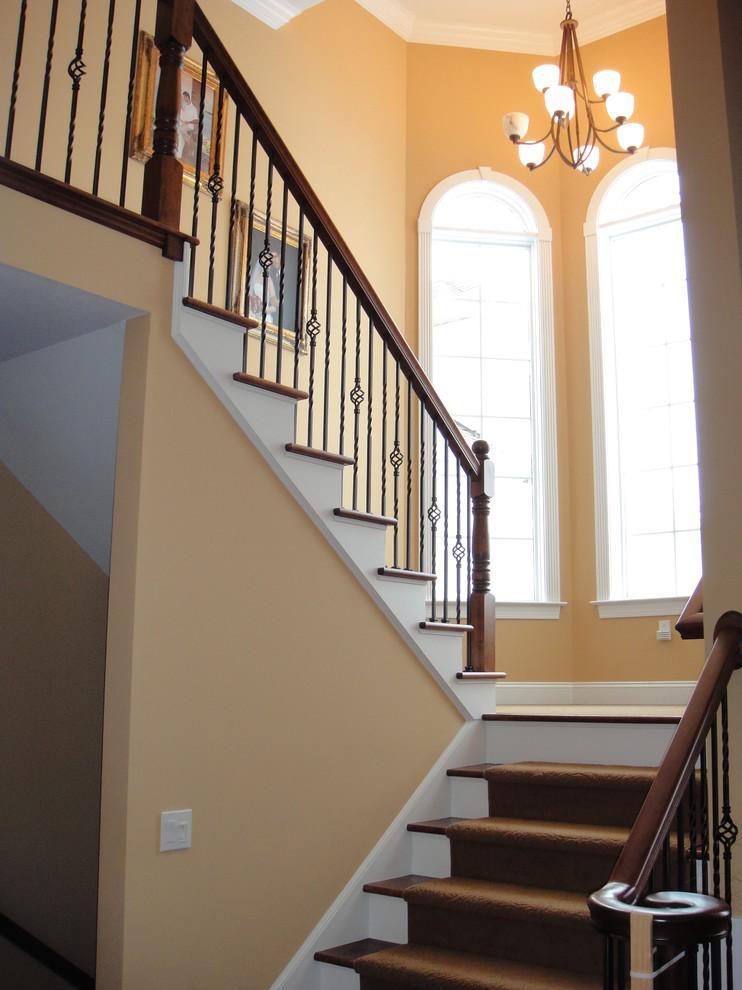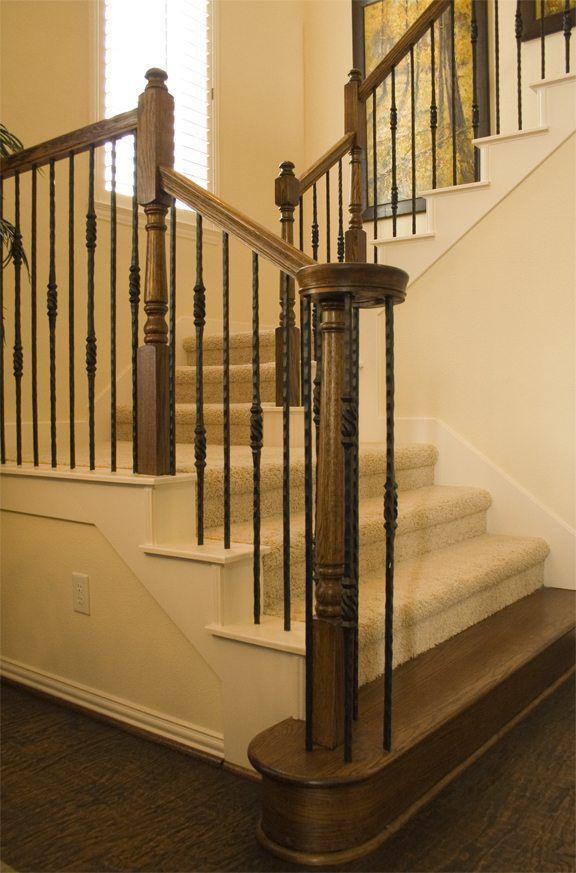The first image is the image on the left, the second image is the image on the right. Analyze the images presented: Is the assertion "One of the stairways curves, while the other stairway has straight sections." valid? Answer yes or no. No. The first image is the image on the left, the second image is the image on the right. Given the left and right images, does the statement "Each image features a non-curved staircase with wooden handrails and wrought iron bars that feature some dimensional decorative element." hold true? Answer yes or no. Yes. 